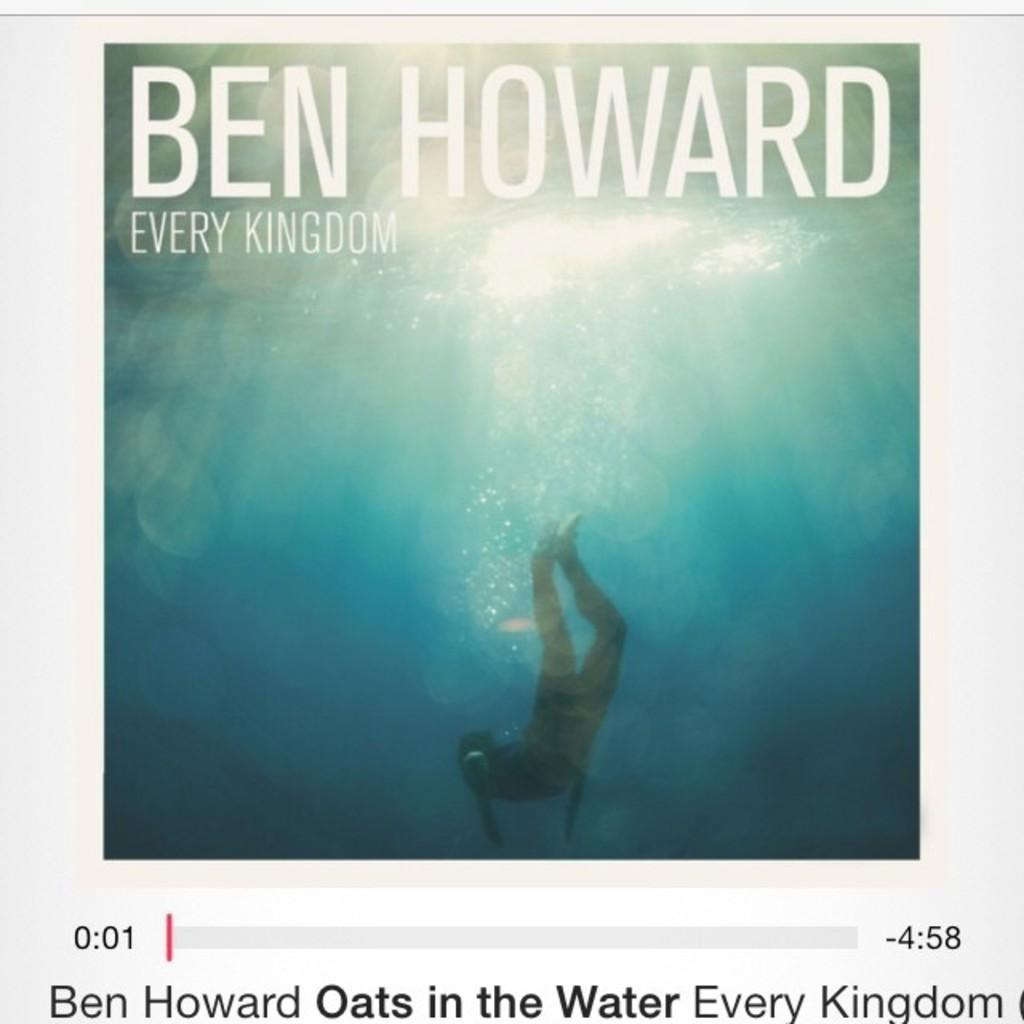Provide a one-sentence caption for the provided image. Ben Howard's Every Kingdom album cover with a man swimming underwater. 